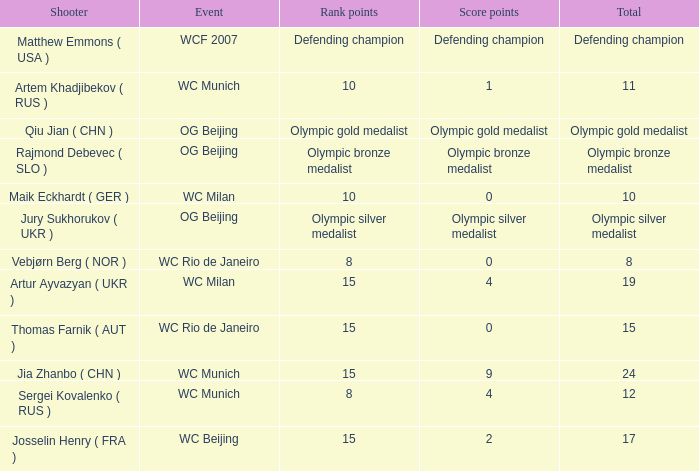With a total of 11, and 10 rank points, what are the score points? 1.0. 